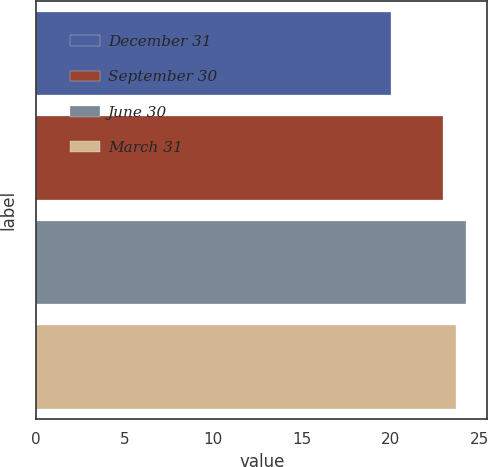Convert chart to OTSL. <chart><loc_0><loc_0><loc_500><loc_500><bar_chart><fcel>December 31<fcel>September 30<fcel>June 30<fcel>March 31<nl><fcel>20<fcel>22.94<fcel>24.25<fcel>23.69<nl></chart> 